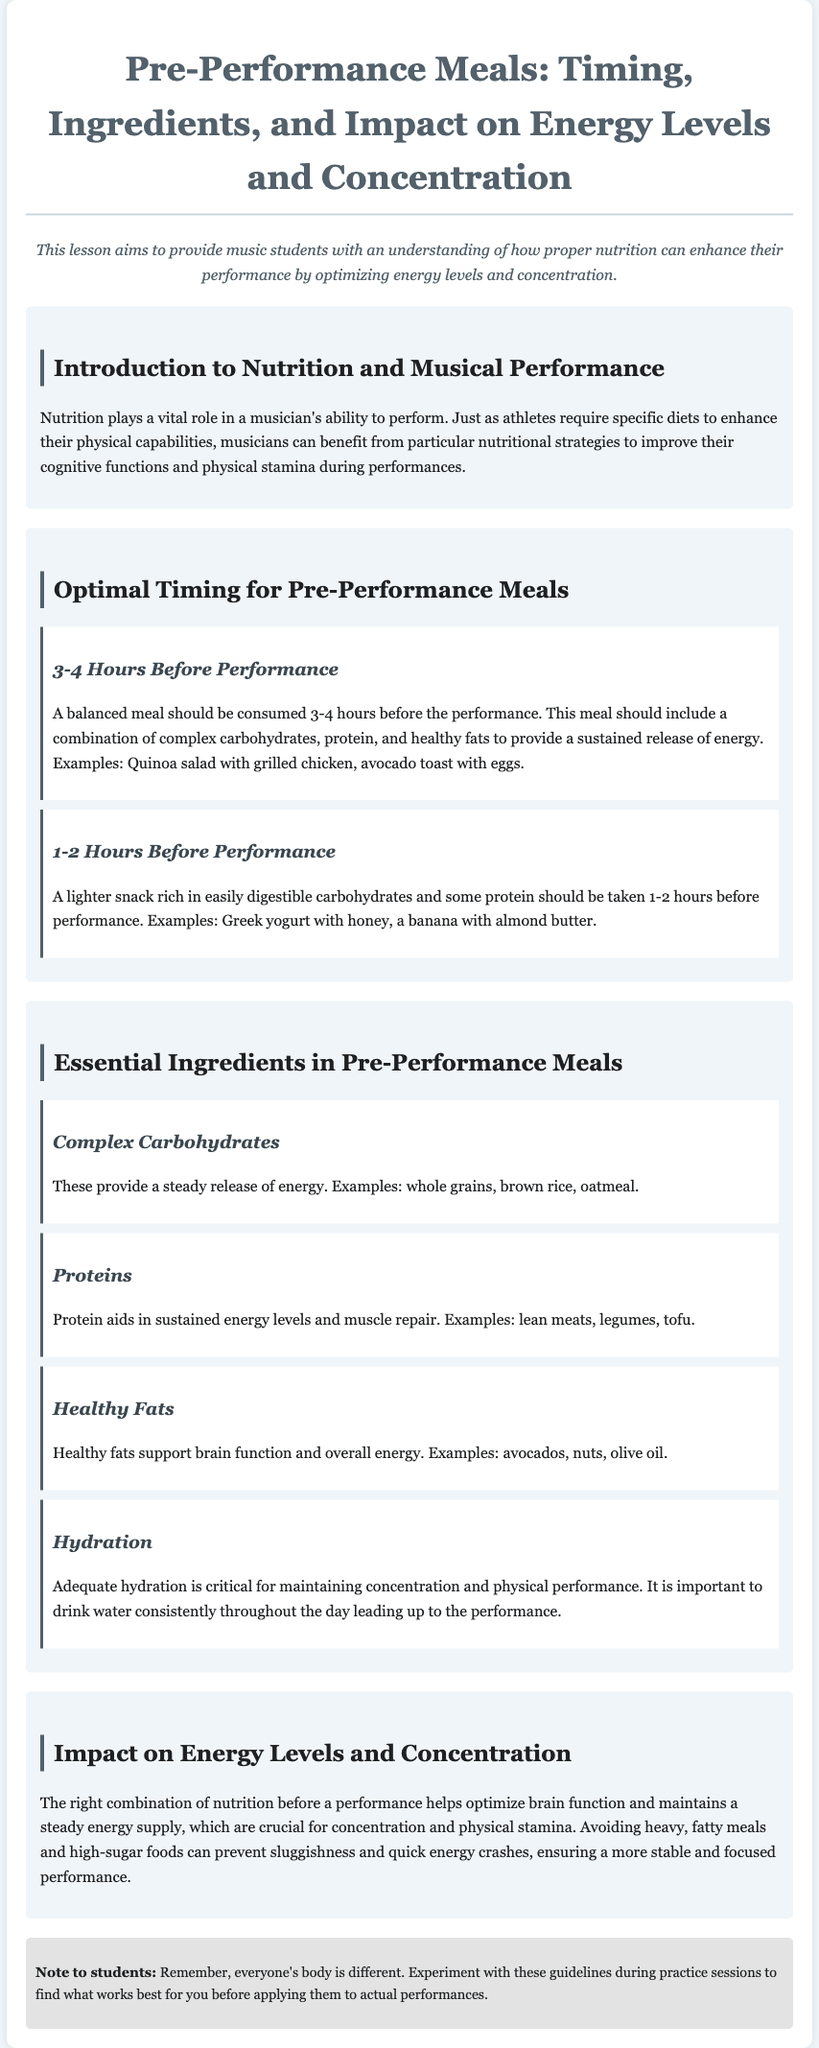What is the title of the lesson plan? The title of the lesson plan is indicated at the top of the document, which is "Pre-Performance Meals: Timing, Ingredients, and Impact".
Answer: Pre-Performance Meals: Timing, Ingredients, and Impact How many hours before performance is a balanced meal recommended? The document specifies that a balanced meal should be consumed 3-4 hours before the performance.
Answer: 3-4 hours What type of carbohydrates are recommended for pre-performance meals? The lesson discusses the importance of complex carbohydrates for sustained energy, such as whole grains and brown rice.
Answer: Complex carbohydrates What is an example of a snack to consume 1-2 hours before the performance? The document provides examples of snacks, including Greek yogurt with honey and a banana with almond butter.
Answer: Greek yogurt with honey How does proper nutrition impact performance? The document explains that the right combination of nutrition helps optimize brain function and maintains a steady energy supply.
Answer: Optimize brain function and maintain energy What is the critical factor for maintaining concentration mentioned in the hydration section? The document emphasizes that adequate hydration is critical for maintaining concentration and physical performance.
Answer: Adequate hydration What should be avoided before a performance according to the impact section? The document advises avoiding heavy, fatty meals and high-sugar foods to prevent sluggishness.
Answer: Heavy, fatty meals and high-sugar foods What is the main purpose of this lesson plan? The document states that the lesson aims to provide music students with an understanding of how proper nutrition can enhance their performance.
Answer: Enhance their performance 